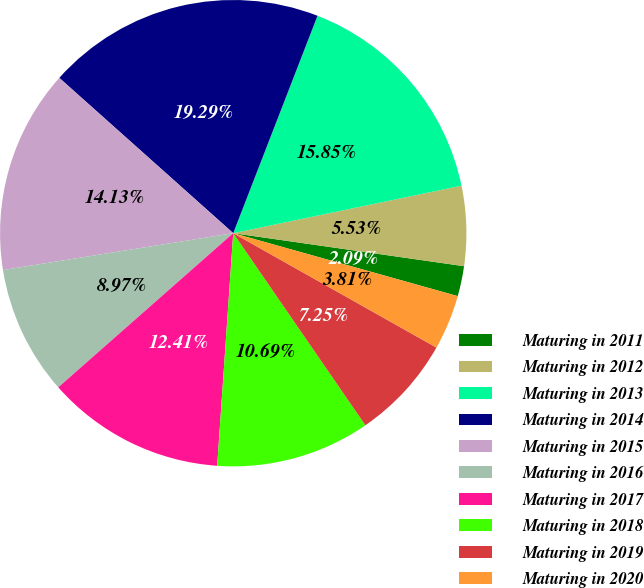<chart> <loc_0><loc_0><loc_500><loc_500><pie_chart><fcel>Maturing in 2011<fcel>Maturing in 2012<fcel>Maturing in 2013<fcel>Maturing in 2014<fcel>Maturing in 2015<fcel>Maturing in 2016<fcel>Maturing in 2017<fcel>Maturing in 2018<fcel>Maturing in 2019<fcel>Maturing in 2020<nl><fcel>2.09%<fcel>5.53%<fcel>15.85%<fcel>19.29%<fcel>14.13%<fcel>8.97%<fcel>12.41%<fcel>10.69%<fcel>7.25%<fcel>3.81%<nl></chart> 